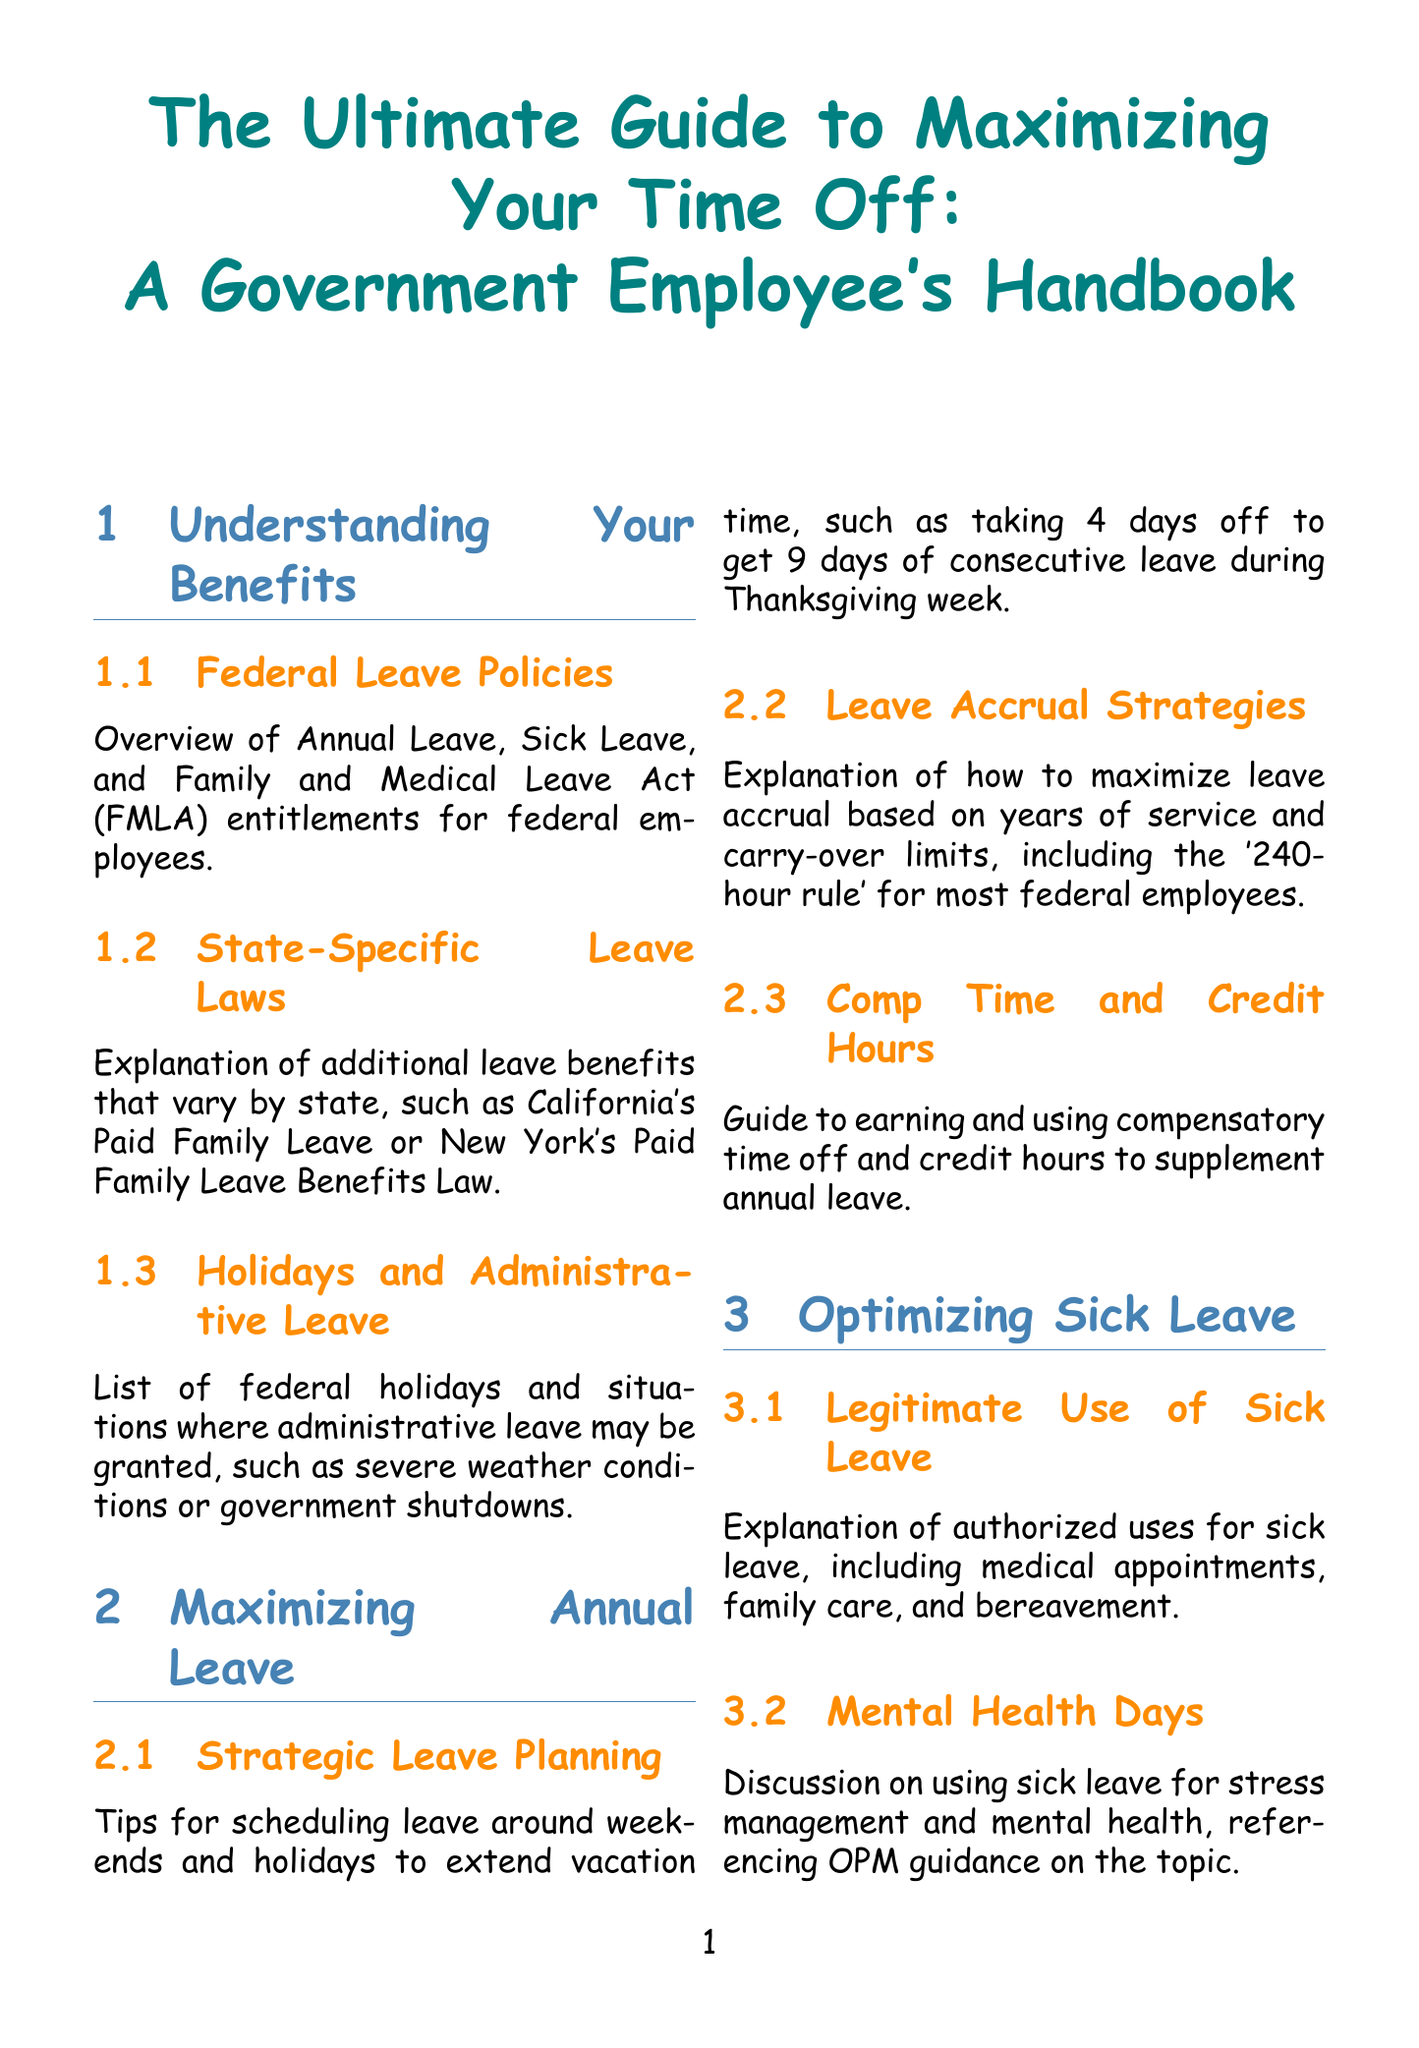what are the types of leave discussed? The document discusses Federal Leave Policies, Annual Leave, Sick Leave, Leave Without Pay, Alternative Work Schedules, Telework Opportunities, Legal Considerations, and Case Studies.
Answer: Federal Leave Policies, Annual Leave, Sick Leave, Leave Without Pay, Alternative Work Schedules, Telework Opportunities, Legal Considerations, Case Studies what is the '240-hour rule'? The '240-hour rule' for most federal employees refers to the carry-over limits on annual leave accrual.
Answer: 240 hours what is one authorized use for sick leave? The document lists medical appointments as one authorized use for sick leave.
Answer: Medical appointments what are the two types of telework mentioned? The document mentions Regular and Situational Telework as types of telework.
Answer: Regular and Situational Telework how can unused sick leave be used for retirement? Unused sick leave can be converted to service credit upon retirement under the FERS system.
Answer: Service credit how much leave can be earned equivalent to 14 days off during summer? The 'Summer Stretch' strategy can turn 14 days of leave into 30 days off.
Answer: 30 days which state is specifically mentioned in state-specific leave laws? California's Paid Family Leave is mentioned in state-specific leave laws.
Answer: California what is one strategy for taking extended vacations? Using Leave Without Pay (LWOP) is one strategy for extending vacations.
Answer: LWOP what is the benefit of a compressed work schedule? A compressed work schedule allows for regular days off without using leave.
Answer: Regular days off what should employees do to avoid potential disciplinary actions regarding leave? Employees should properly request and document leave to avoid potential disciplinary actions.
Answer: Properly request and document leave 